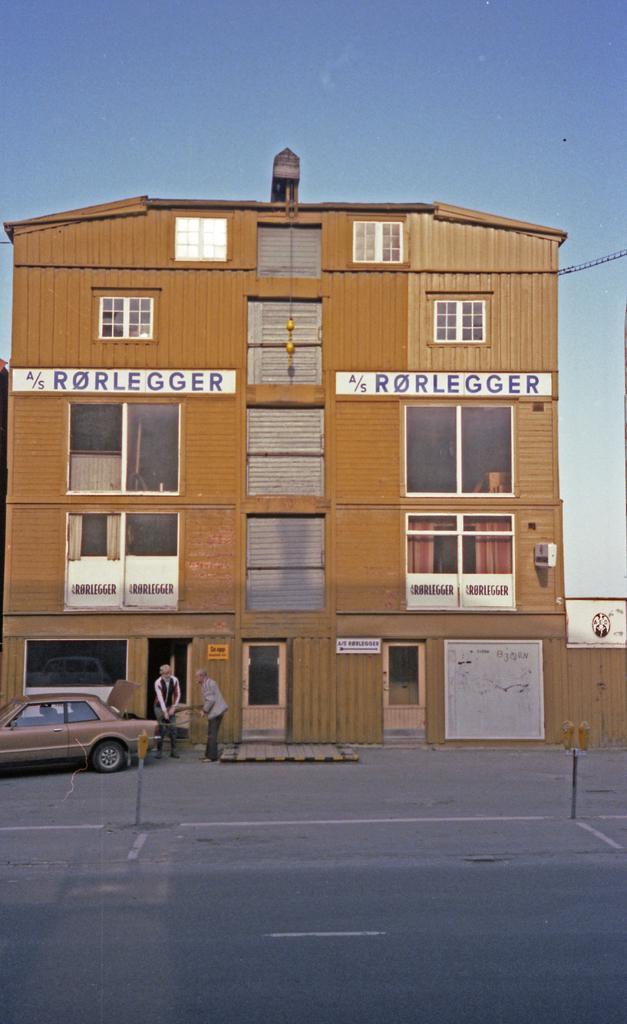In one or two sentences, can you explain what this image depicts? In this image, we can see a building with some text. There are a few people. We can see the ground with some objects. We can also see a vehicle. There are a few poles and boards. We can see the sky and also an object on the right. 